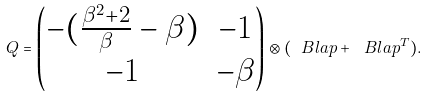<formula> <loc_0><loc_0><loc_500><loc_500>Q = \begin{pmatrix} - ( \frac { \beta ^ { 2 } + 2 } { \beta } - \beta ) & - 1 \\ - 1 & - \beta \end{pmatrix} \otimes ( \ B l a p + \ B l a p ^ { T } ) .</formula> 